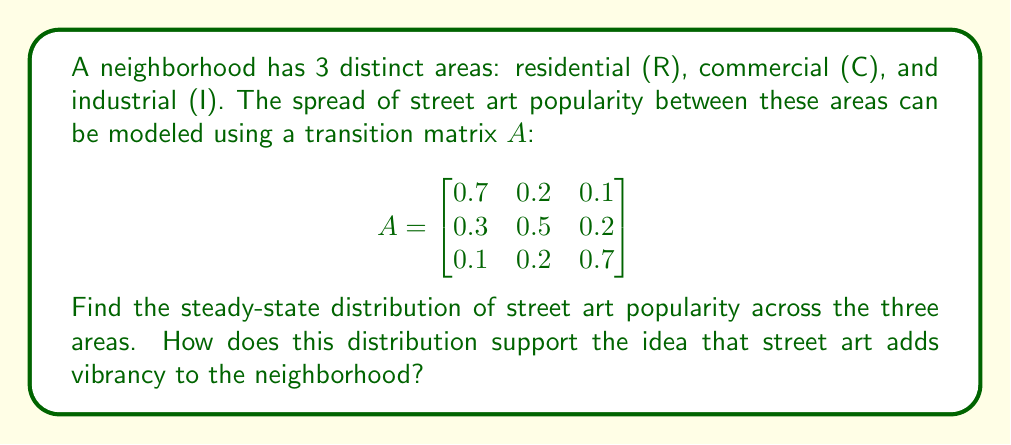Could you help me with this problem? To find the steady-state distribution, we need to find the eigenvector corresponding to the eigenvalue 1 of the transition matrix A.

Step 1: Verify that 1 is an eigenvalue of A.
Det(A - I) = 0, where I is the 3x3 identity matrix.

Step 2: Find the eigenvector $\vec{v}$ that satisfies $A\vec{v} = \vec{v}$.
$$(A - I)\vec{v} = \vec{0}$$

$$\begin{bmatrix}
-0.3 & 0.2 & 0.1 \\
0.3 & -0.5 & 0.2 \\
0.1 & 0.2 & -0.3
\end{bmatrix}\begin{bmatrix}
v_1 \\ v_2 \\ v_3
\end{bmatrix} = \begin{bmatrix}
0 \\ 0 \\ 0
\end{bmatrix}$$

Step 3: Solve the system of equations:
$-0.3v_1 + 0.2v_2 + 0.1v_3 = 0$
$0.3v_1 - 0.5v_2 + 0.2v_3 = 0$
$0.1v_1 + 0.2v_2 - 0.3v_3 = 0$

Step 4: Find a non-trivial solution:
$v_1 = 5$, $v_2 = 6$, $v_3 = 4$

Step 5: Normalize the eigenvector to get the steady-state distribution:
$$\vec{p} = \frac{1}{5+6+4}\begin{bmatrix}
5 \\ 6 \\ 4
\end{bmatrix} = \begin{bmatrix}
0.3333 \\ 0.4000 \\ 0.2667
\end{bmatrix}$$

This distribution supports the idea that street art adds vibrancy to the neighborhood because:
1. It shows a significant presence in all areas, not just one.
2. The highest concentration (40%) is in the commercial area, which is typically the most visible and trafficked part of a neighborhood.
3. There's a balanced distribution between residential (33.33%) and industrial (26.67%) areas, suggesting widespread appeal and integration into the community.
Answer: Steady-state distribution: $(0.3333, 0.4000, 0.2667)$ for (R, C, I) respectively. 